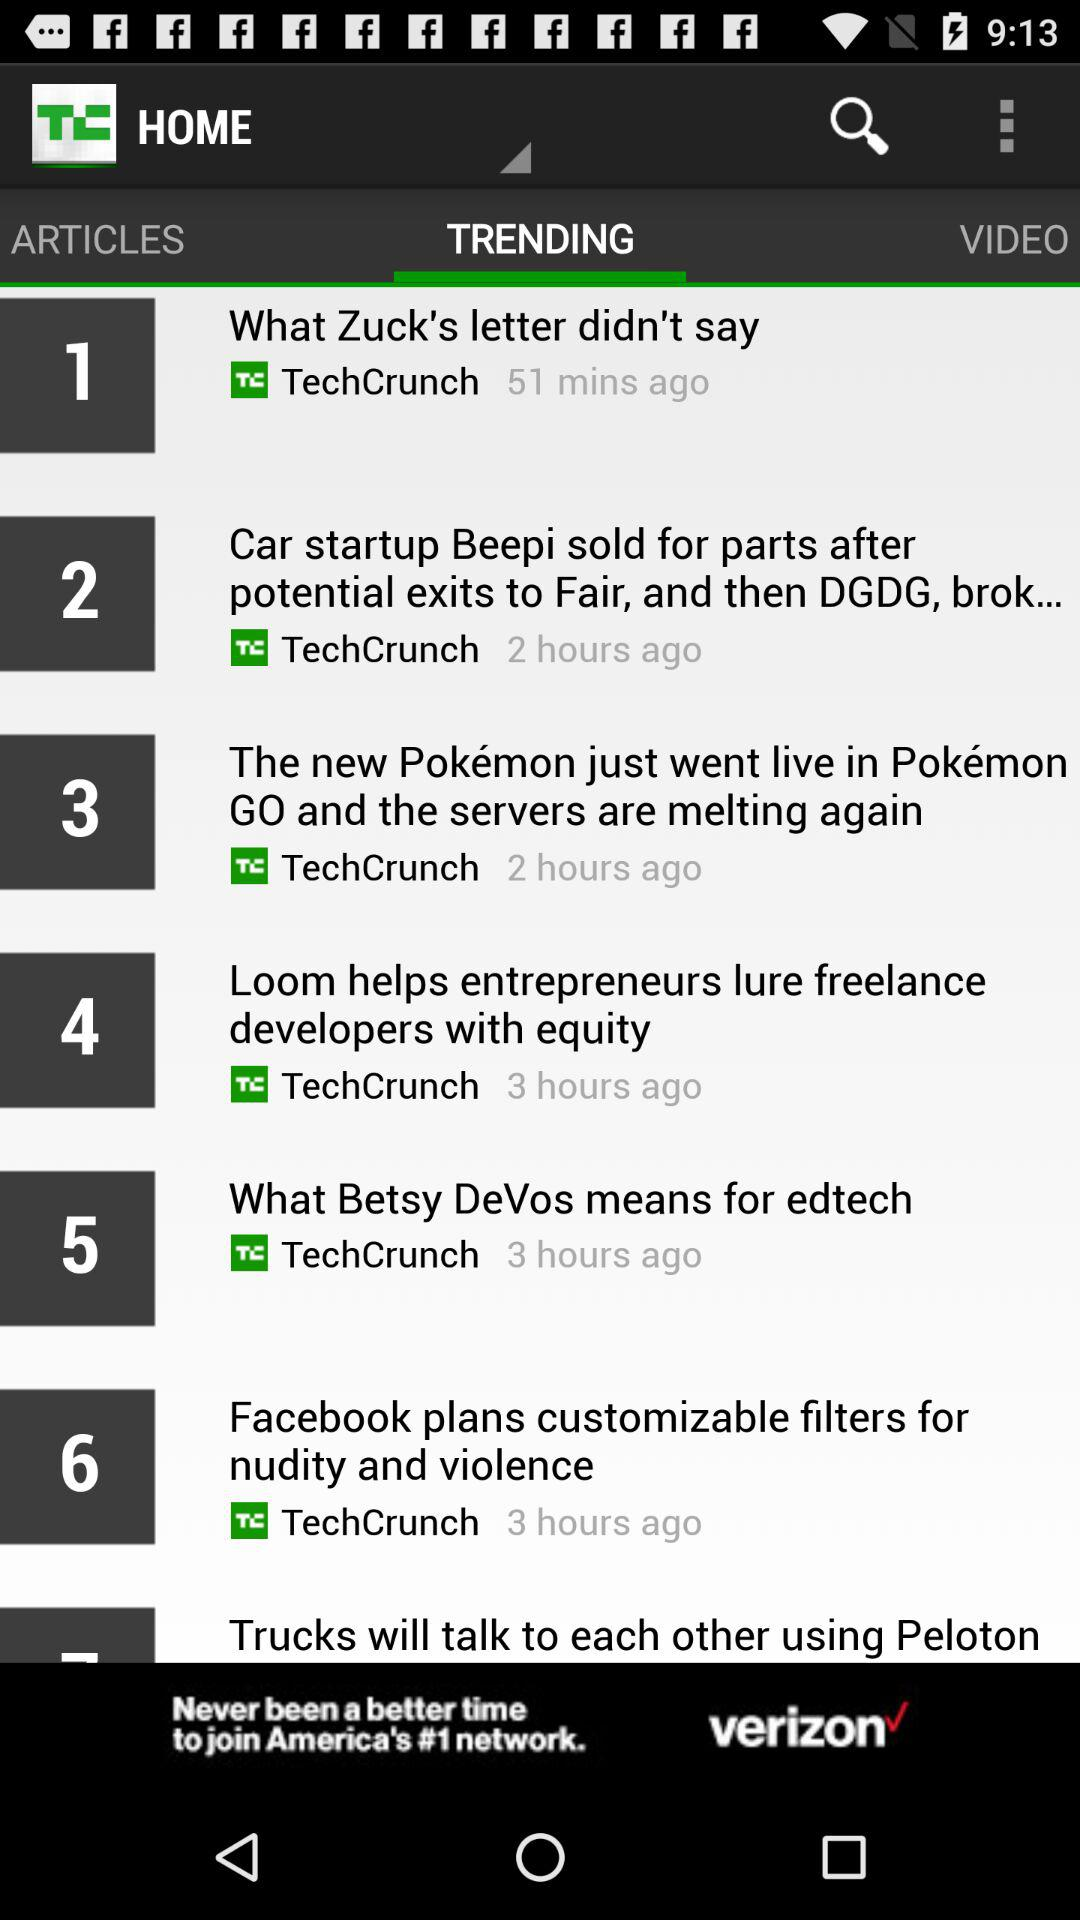What's the number 1 trending article? The number 1 trending article is "What Zuck's letter didn't say". 